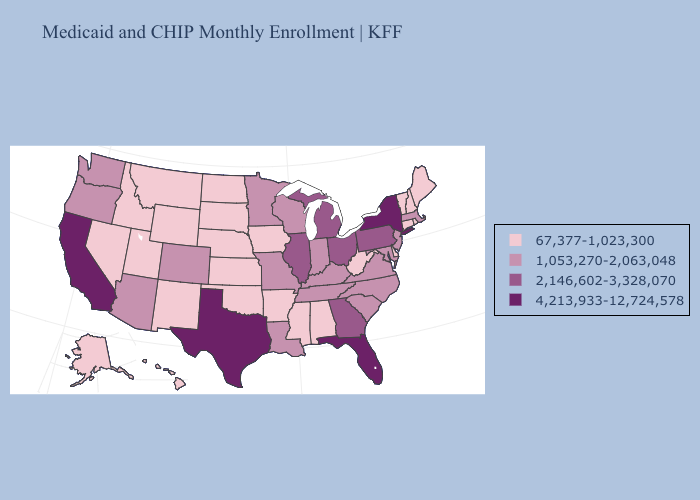Among the states that border North Carolina , which have the highest value?
Concise answer only. Georgia. Among the states that border Florida , which have the highest value?
Concise answer only. Georgia. Name the states that have a value in the range 4,213,933-12,724,578?
Quick response, please. California, Florida, New York, Texas. Does North Dakota have the highest value in the USA?
Give a very brief answer. No. Among the states that border Montana , which have the lowest value?
Short answer required. Idaho, North Dakota, South Dakota, Wyoming. What is the value of Massachusetts?
Quick response, please. 1,053,270-2,063,048. Name the states that have a value in the range 1,053,270-2,063,048?
Be succinct. Arizona, Colorado, Indiana, Kentucky, Louisiana, Maryland, Massachusetts, Minnesota, Missouri, New Jersey, North Carolina, Oregon, South Carolina, Tennessee, Virginia, Washington, Wisconsin. Does Missouri have the lowest value in the USA?
Be succinct. No. Name the states that have a value in the range 4,213,933-12,724,578?
Concise answer only. California, Florida, New York, Texas. Does the map have missing data?
Short answer required. No. Is the legend a continuous bar?
Write a very short answer. No. Name the states that have a value in the range 1,053,270-2,063,048?
Concise answer only. Arizona, Colorado, Indiana, Kentucky, Louisiana, Maryland, Massachusetts, Minnesota, Missouri, New Jersey, North Carolina, Oregon, South Carolina, Tennessee, Virginia, Washington, Wisconsin. Does Delaware have a lower value than New Hampshire?
Short answer required. No. What is the value of Virginia?
Short answer required. 1,053,270-2,063,048. What is the value of Hawaii?
Short answer required. 67,377-1,023,300. 